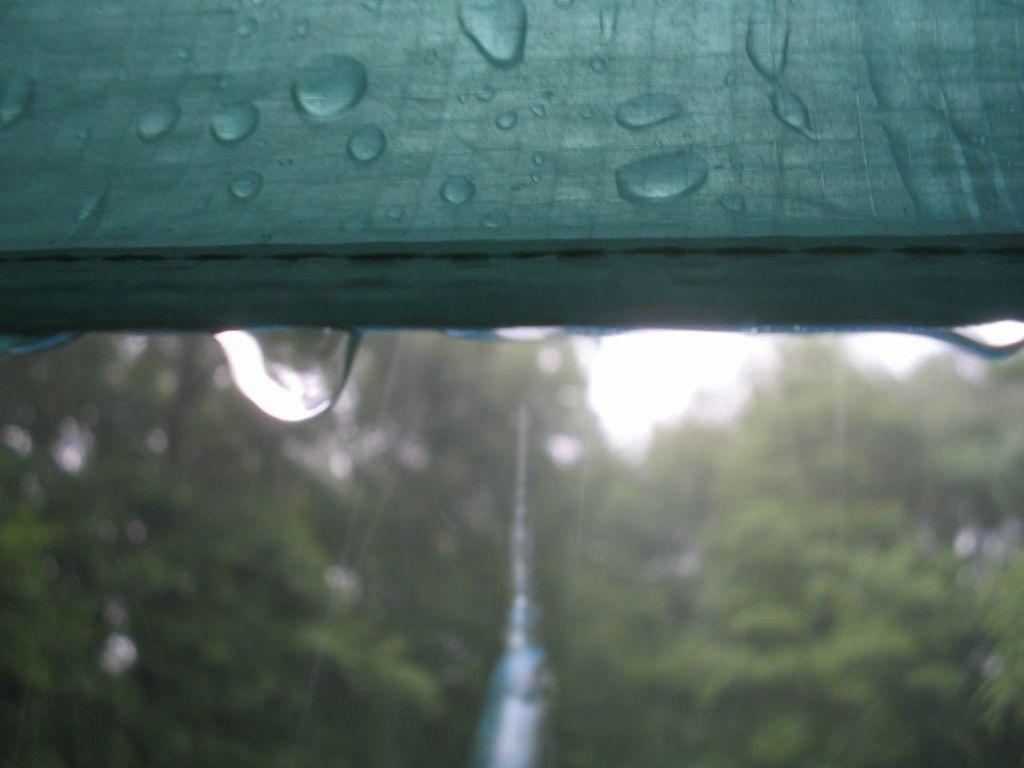What is covering the top part of the image? There is a green colored cloth or cover at the top of the image. What can be observed on the cloth or cover? There are droplets of water on the cloth or cover. What is the weather like outside? It is raining outside. Can you describe the background of the image? The background of the image is blurred. What advice is given on the clocks in the image? There are no clocks present in the image, so no advice can be given. 